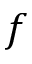Convert formula to latex. <formula><loc_0><loc_0><loc_500><loc_500>f</formula> 